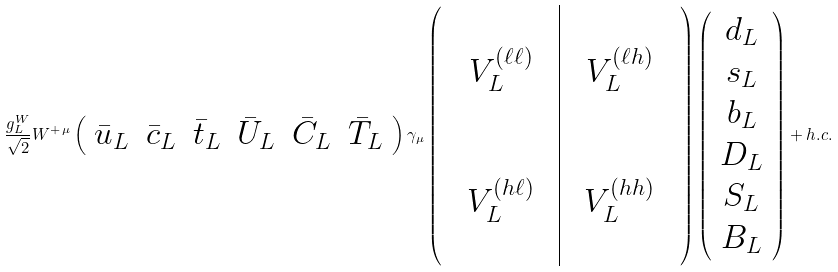<formula> <loc_0><loc_0><loc_500><loc_500>\frac { g _ { L } ^ { W } } { \sqrt { 2 } } W ^ { + \, \mu } \left ( \begin{array} { c c c c c c } \bar { u } _ { L } & \bar { c } _ { L } & \bar { t } _ { L } & \bar { U } _ { L } & \bar { C } _ { L } & \bar { T } _ { L } \end{array} \right ) \gamma _ { \mu } \left ( \begin{array} { c c c | c c c } & & & & & \\ & V _ { L } ^ { ( \ell \ell ) } & & & V _ { L } ^ { ( \ell h ) } & \\ & & & & & \\ & & & & & \\ & V _ { L } ^ { ( h \ell ) } & & & V _ { L } ^ { ( h h ) } & \\ & & & & & \end{array} \right ) \left ( \begin{array} { c } d _ { L } \\ s _ { L } \\ b _ { L } \\ D _ { L } \\ S _ { L } \\ B _ { L } \end{array} \right ) + h . c .</formula> 